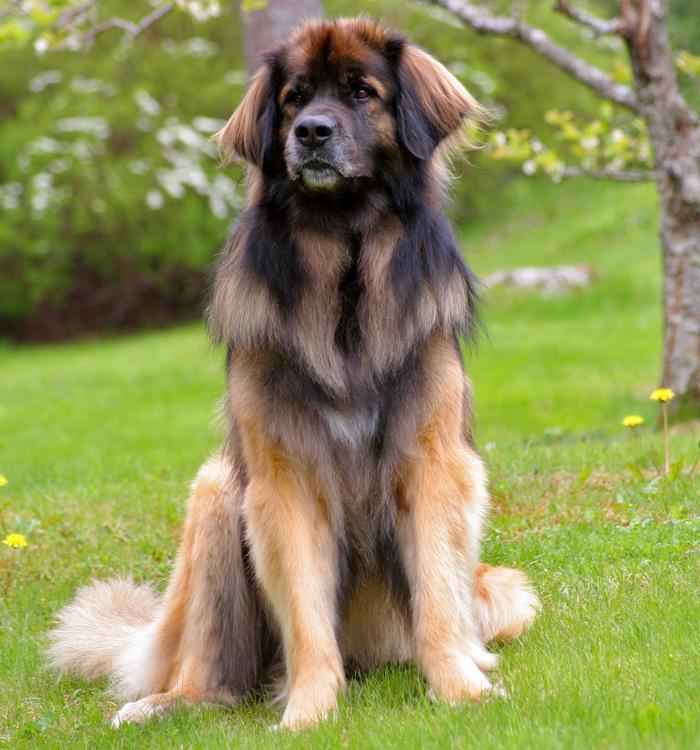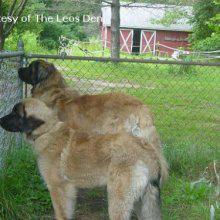The first image is the image on the left, the second image is the image on the right. Considering the images on both sides, is "In one image there are multiple dogs sitting outside." valid? Answer yes or no. No. The first image is the image on the left, the second image is the image on the right. Examine the images to the left and right. Is the description "There are at most three dogs." accurate? Answer yes or no. Yes. 